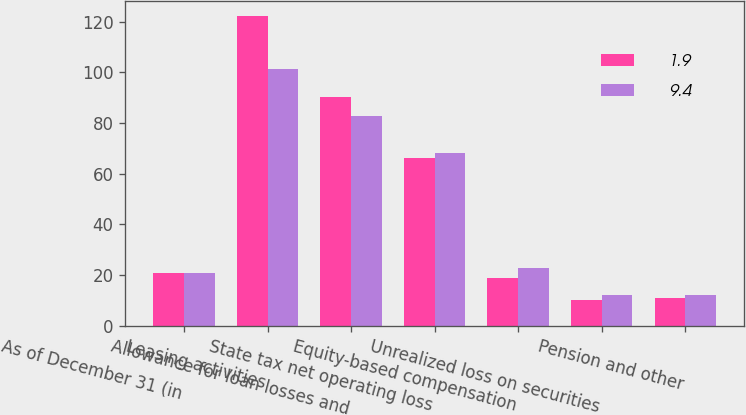Convert chart to OTSL. <chart><loc_0><loc_0><loc_500><loc_500><stacked_bar_chart><ecel><fcel>As of December 31 (in<fcel>Leasing activities<fcel>Allowance for loan losses and<fcel>State tax net operating loss<fcel>Equity-based compensation<fcel>Unrealized loss on securities<fcel>Pension and other<nl><fcel>1.9<fcel>20.95<fcel>122.2<fcel>90.2<fcel>66.3<fcel>19<fcel>10.2<fcel>10.9<nl><fcel>9.4<fcel>20.95<fcel>101.5<fcel>82.7<fcel>68<fcel>22.9<fcel>12<fcel>12.2<nl></chart> 